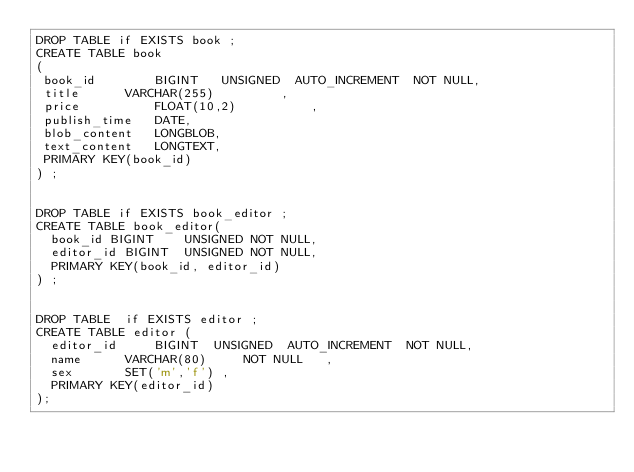<code> <loc_0><loc_0><loc_500><loc_500><_SQL_>DROP TABLE if EXISTS book ;
CREATE TABLE book
(
 book_id       	BIGINT   UNSIGNED  AUTO_INCREMENT  NOT NULL,
 title     	VARCHAR(255)         ,
 price      	FLOAT(10,2)          ,
 publish_time	DATE,
 blob_content   LONGBLOB,
 text_content   LONGTEXT,
 PRIMARY KEY(book_id)
) ;


DROP TABLE if EXISTS book_editor ;
CREATE TABLE book_editor(
  book_id BIGINT    UNSIGNED NOT NULL,
  editor_id BIGINT  UNSIGNED NOT NULL,
  PRIMARY KEY(book_id, editor_id)
) ;


DROP TABLE  if EXISTS editor ;
CREATE TABLE editor (
  editor_id     BIGINT  UNSIGNED  AUTO_INCREMENT  NOT NULL,
  name    	VARCHAR(80)     NOT NULL   ,
  sex		SET('m','f') ,
  PRIMARY KEY(editor_id)
);


</code> 